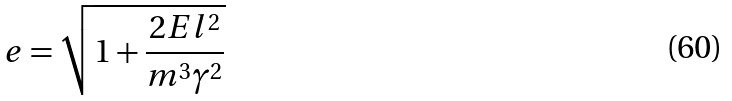<formula> <loc_0><loc_0><loc_500><loc_500>e = \sqrt { 1 + \frac { 2 E l ^ { 2 } } { m ^ { 3 } \gamma ^ { 2 } } }</formula> 